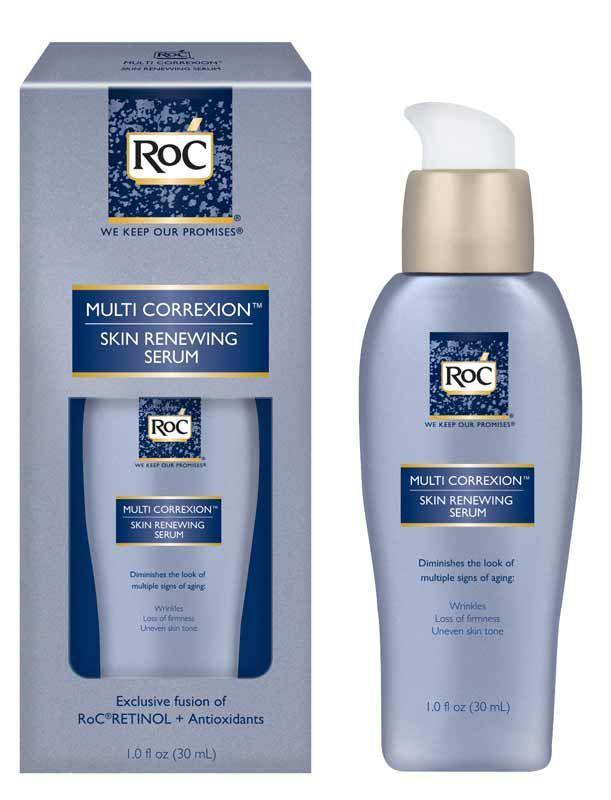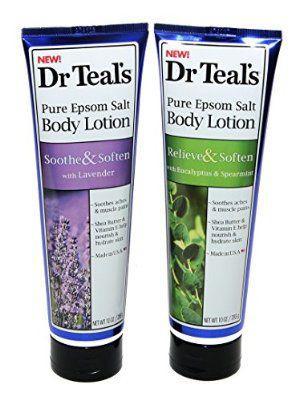The first image is the image on the left, the second image is the image on the right. Given the left and right images, does the statement "Each image contains at least three skincare products." hold true? Answer yes or no. No. The first image is the image on the left, the second image is the image on the right. Given the left and right images, does the statement "Each image shows at least three plastic bottles of a product in different colors." hold true? Answer yes or no. No. 